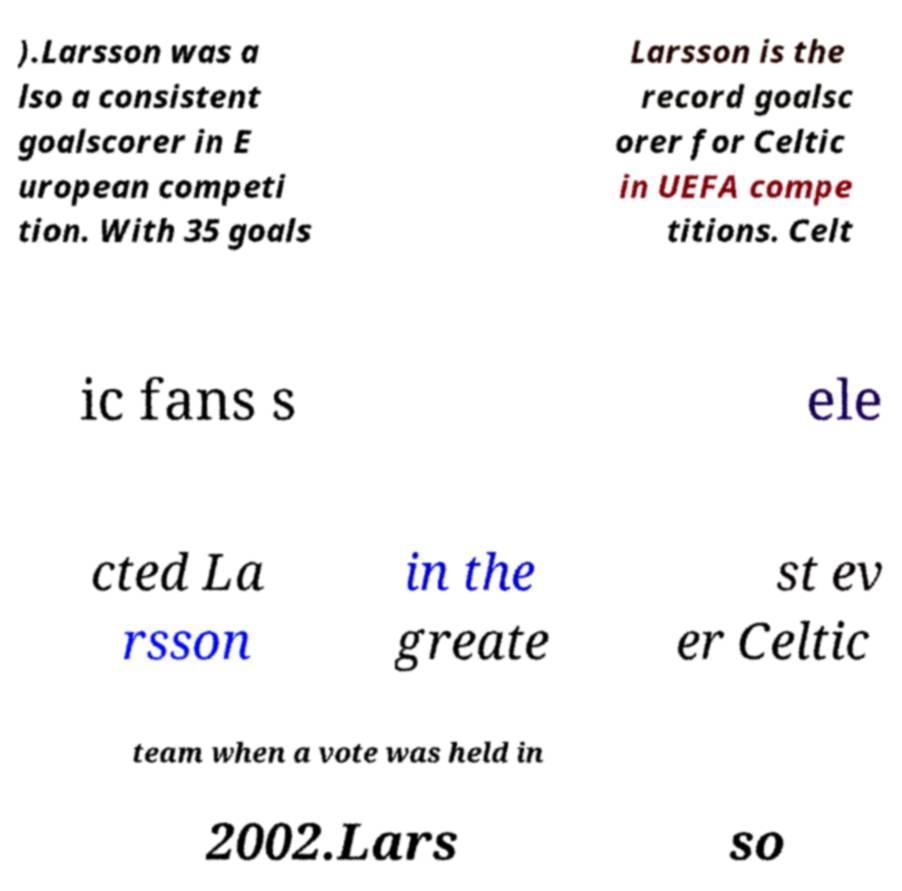There's text embedded in this image that I need extracted. Can you transcribe it verbatim? ).Larsson was a lso a consistent goalscorer in E uropean competi tion. With 35 goals Larsson is the record goalsc orer for Celtic in UEFA compe titions. Celt ic fans s ele cted La rsson in the greate st ev er Celtic team when a vote was held in 2002.Lars so 